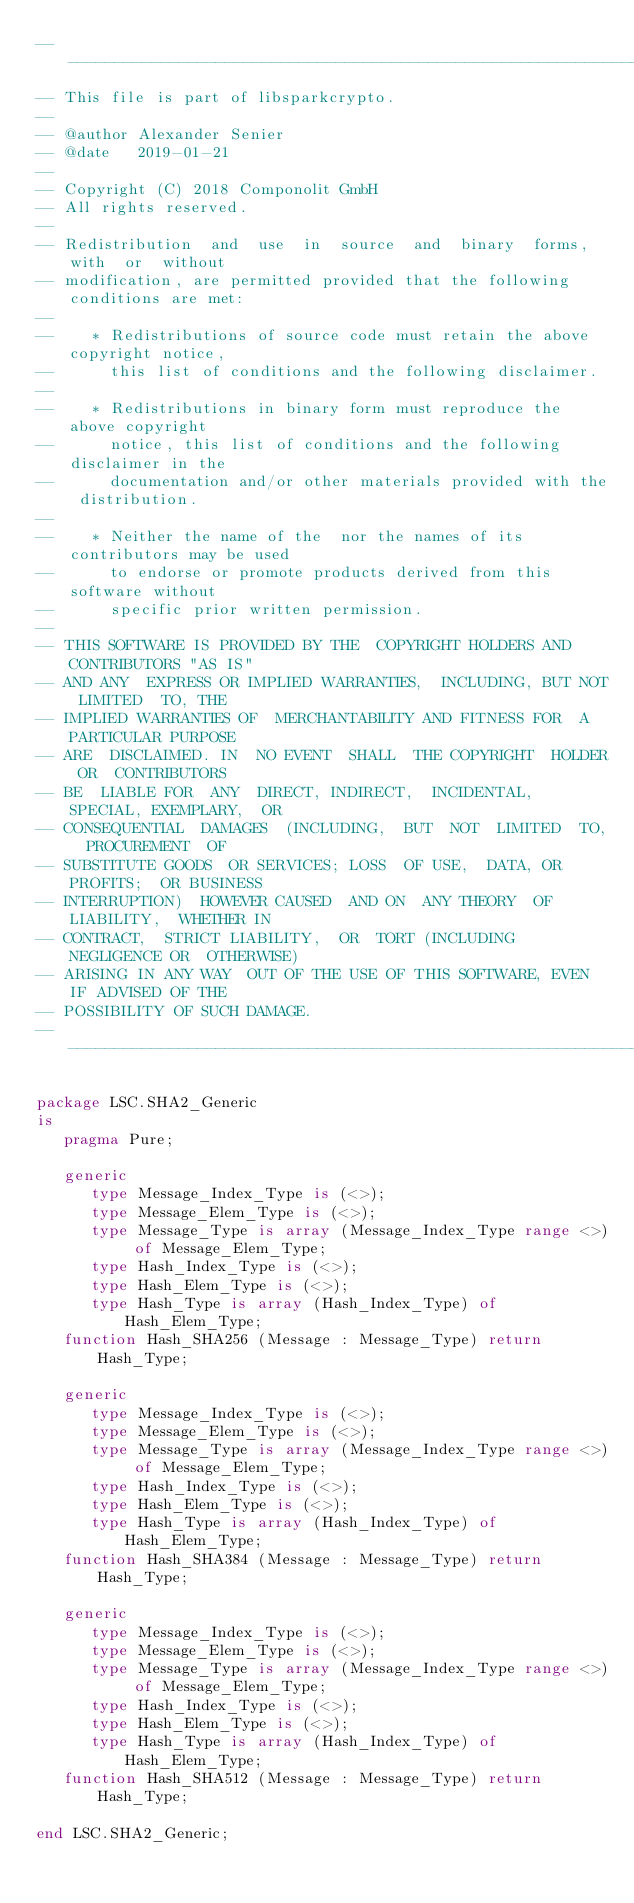<code> <loc_0><loc_0><loc_500><loc_500><_Ada_>-------------------------------------------------------------------------------
-- This file is part of libsparkcrypto.
--
-- @author Alexander Senier
-- @date   2019-01-21
--
-- Copyright (C) 2018 Componolit GmbH
-- All rights reserved.
--
-- Redistribution  and  use  in  source  and  binary  forms,  with  or  without
-- modification, are permitted provided that the following conditions are met:
--
--    * Redistributions of source code must retain the above copyright notice,
--      this list of conditions and the following disclaimer.
--
--    * Redistributions in binary form must reproduce the above copyright
--      notice, this list of conditions and the following disclaimer in the
--      documentation and/or other materials provided with the distribution.
--
--    * Neither the name of the  nor the names of its contributors may be used
--      to endorse or promote products derived from this software without
--      specific prior written permission.
--
-- THIS SOFTWARE IS PROVIDED BY THE  COPYRIGHT HOLDERS AND CONTRIBUTORS "AS IS"
-- AND ANY  EXPRESS OR IMPLIED WARRANTIES,  INCLUDING, BUT NOT LIMITED  TO, THE
-- IMPLIED WARRANTIES OF  MERCHANTABILITY AND FITNESS FOR  A PARTICULAR PURPOSE
-- ARE  DISCLAIMED. IN  NO EVENT  SHALL  THE COPYRIGHT  HOLDER OR  CONTRIBUTORS
-- BE  LIABLE FOR  ANY  DIRECT, INDIRECT,  INCIDENTAL,  SPECIAL, EXEMPLARY,  OR
-- CONSEQUENTIAL  DAMAGES  (INCLUDING,  BUT  NOT  LIMITED  TO,  PROCUREMENT  OF
-- SUBSTITUTE GOODS  OR SERVICES; LOSS  OF USE,  DATA, OR PROFITS;  OR BUSINESS
-- INTERRUPTION)  HOWEVER CAUSED  AND ON  ANY THEORY  OF LIABILITY,  WHETHER IN
-- CONTRACT,  STRICT LIABILITY,  OR  TORT (INCLUDING  NEGLIGENCE OR  OTHERWISE)
-- ARISING IN ANY WAY  OUT OF THE USE OF THIS SOFTWARE, EVEN  IF ADVISED OF THE
-- POSSIBILITY OF SUCH DAMAGE.
-------------------------------------------------------------------------------

package LSC.SHA2_Generic
is
   pragma Pure;

   generic
      type Message_Index_Type is (<>);
      type Message_Elem_Type is (<>);
      type Message_Type is array (Message_Index_Type range <>) of Message_Elem_Type;
      type Hash_Index_Type is (<>);
      type Hash_Elem_Type is (<>);
      type Hash_Type is array (Hash_Index_Type) of Hash_Elem_Type;
   function Hash_SHA256 (Message : Message_Type) return Hash_Type;

   generic
      type Message_Index_Type is (<>);
      type Message_Elem_Type is (<>);
      type Message_Type is array (Message_Index_Type range <>) of Message_Elem_Type;
      type Hash_Index_Type is (<>);
      type Hash_Elem_Type is (<>);
      type Hash_Type is array (Hash_Index_Type) of Hash_Elem_Type;
   function Hash_SHA384 (Message : Message_Type) return Hash_Type;

   generic
      type Message_Index_Type is (<>);
      type Message_Elem_Type is (<>);
      type Message_Type is array (Message_Index_Type range <>) of Message_Elem_Type;
      type Hash_Index_Type is (<>);
      type Hash_Elem_Type is (<>);
      type Hash_Type is array (Hash_Index_Type) of Hash_Elem_Type;
   function Hash_SHA512 (Message : Message_Type) return Hash_Type;

end LSC.SHA2_Generic;
</code> 